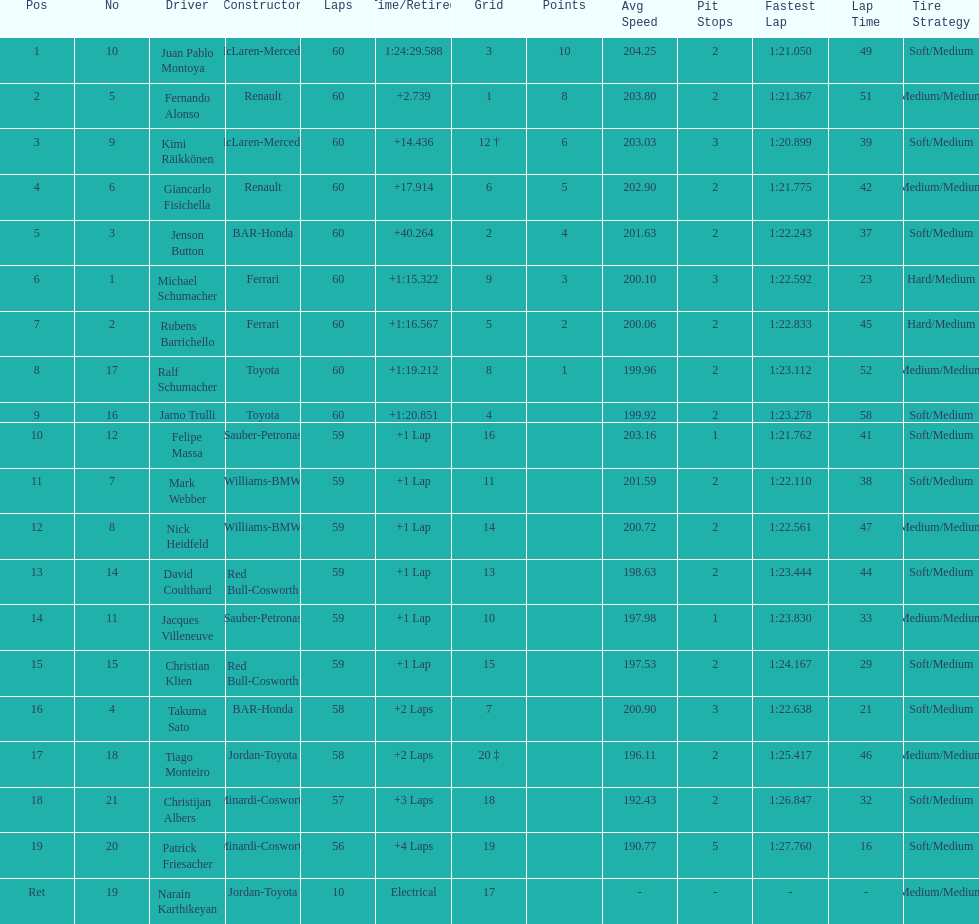Which driver in the top 8, drives a mclaran-mercedes but is not in first place? Kimi Räikkönen. 